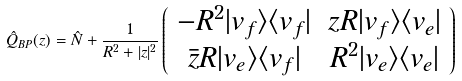Convert formula to latex. <formula><loc_0><loc_0><loc_500><loc_500>\hat { Q } _ { B P } ( z ) = \hat { N } + \frac { 1 } { R ^ { 2 } + | z | ^ { 2 } } \left ( \begin{array} { c c } - R ^ { 2 } | v _ { f } \rangle \langle v _ { f } | & z R | v _ { f } \rangle \langle v _ { e } | \\ \bar { z } R | v _ { e } \rangle \langle v _ { f } | & R ^ { 2 } | v _ { e } \rangle \langle v _ { e } | \end{array} \right )</formula> 